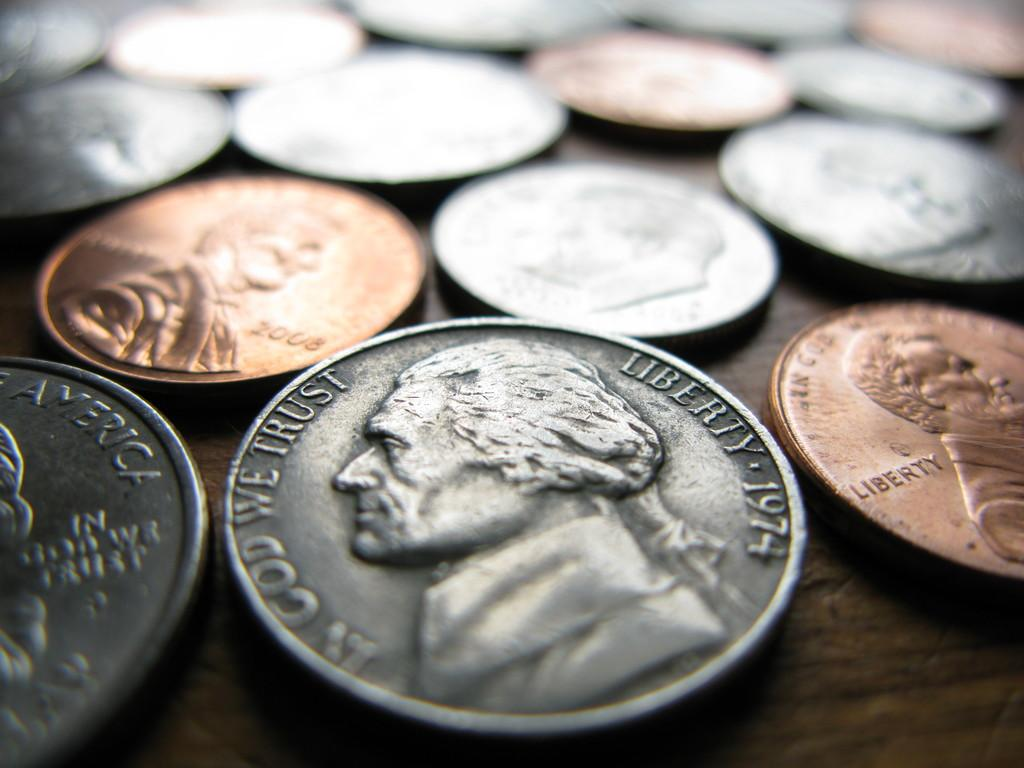<image>
Relay a brief, clear account of the picture shown. Several coins from The United States of America sit on top of a wooden table 